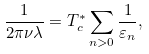Convert formula to latex. <formula><loc_0><loc_0><loc_500><loc_500>\frac { 1 } { 2 \pi \nu \lambda } = T _ { c } ^ { * } \sum _ { n > 0 } \frac { 1 } { \varepsilon _ { n } } ,</formula> 